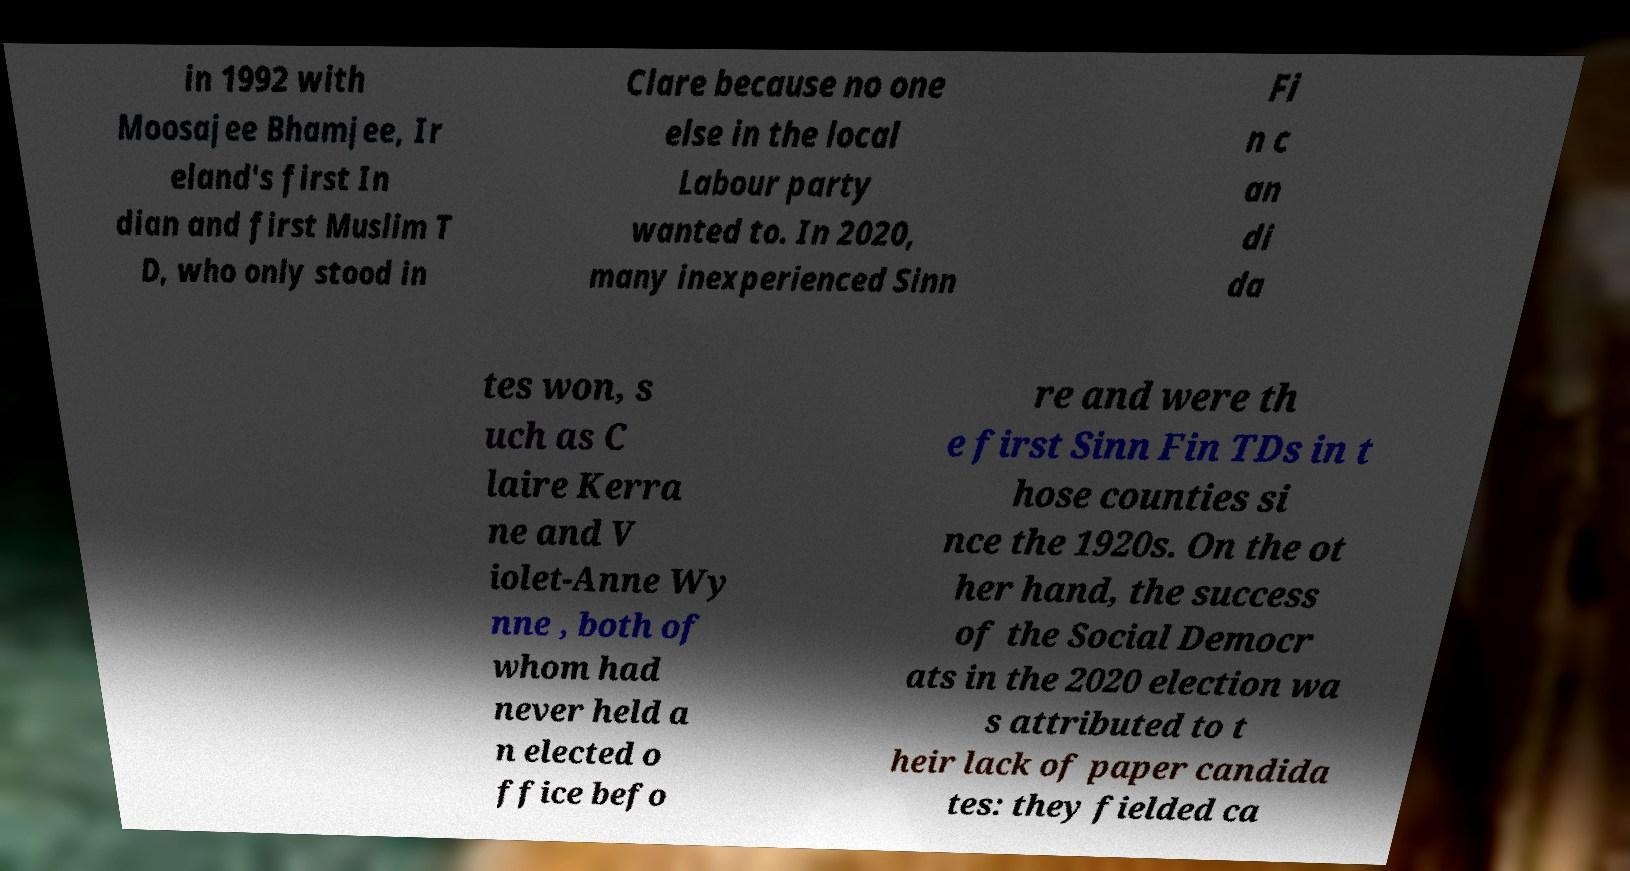What messages or text are displayed in this image? I need them in a readable, typed format. in 1992 with Moosajee Bhamjee, Ir eland's first In dian and first Muslim T D, who only stood in Clare because no one else in the local Labour party wanted to. In 2020, many inexperienced Sinn Fi n c an di da tes won, s uch as C laire Kerra ne and V iolet-Anne Wy nne , both of whom had never held a n elected o ffice befo re and were th e first Sinn Fin TDs in t hose counties si nce the 1920s. On the ot her hand, the success of the Social Democr ats in the 2020 election wa s attributed to t heir lack of paper candida tes: they fielded ca 